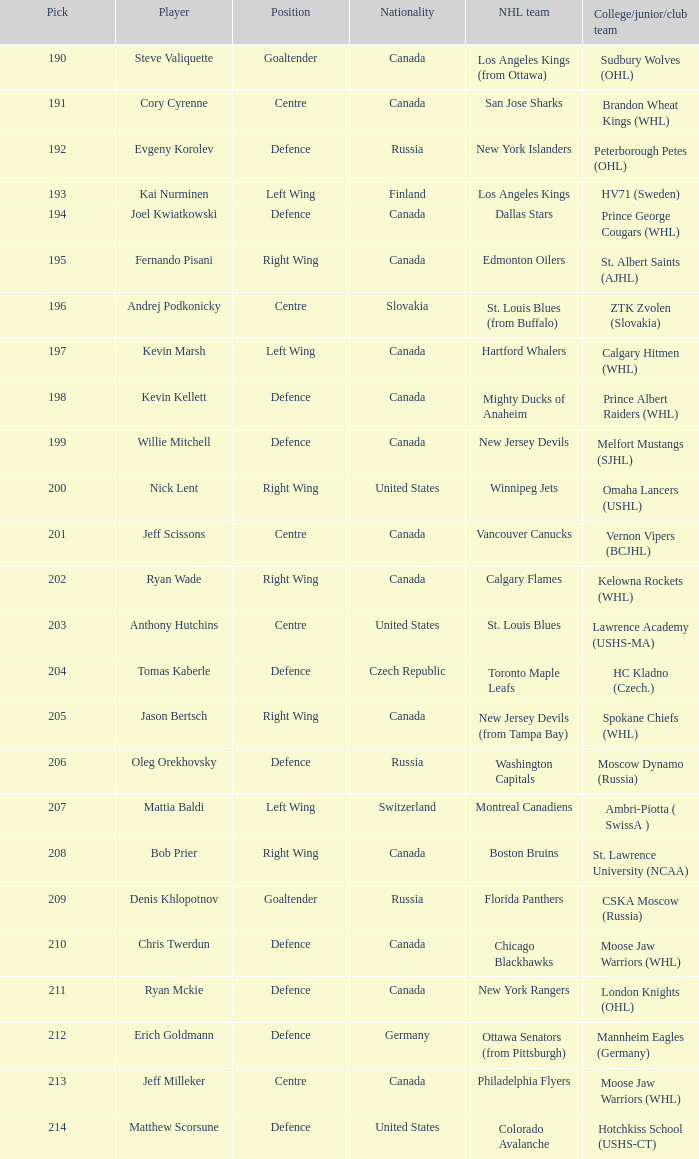Identify the choice for matthew scorsune. 214.0. 